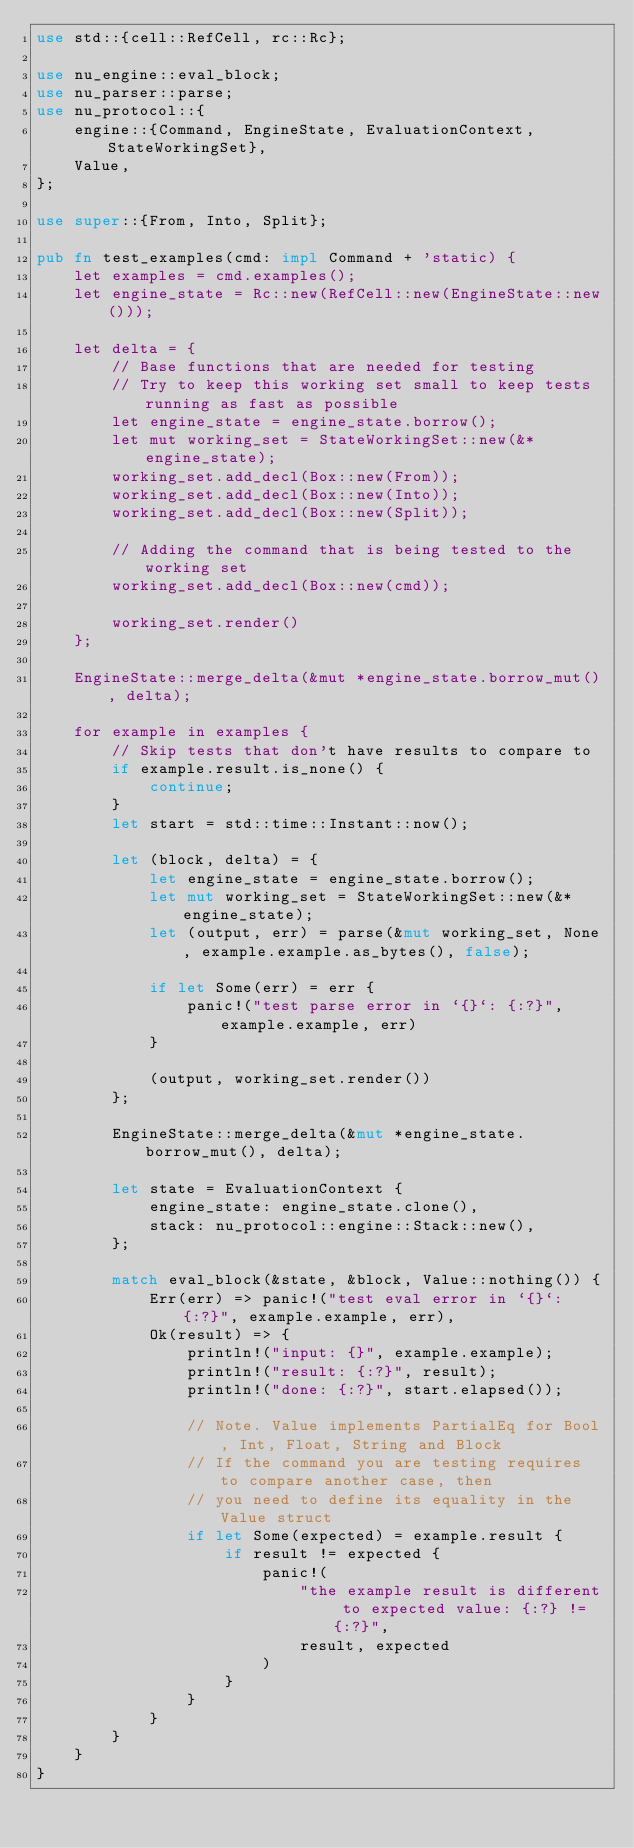<code> <loc_0><loc_0><loc_500><loc_500><_Rust_>use std::{cell::RefCell, rc::Rc};

use nu_engine::eval_block;
use nu_parser::parse;
use nu_protocol::{
    engine::{Command, EngineState, EvaluationContext, StateWorkingSet},
    Value,
};

use super::{From, Into, Split};

pub fn test_examples(cmd: impl Command + 'static) {
    let examples = cmd.examples();
    let engine_state = Rc::new(RefCell::new(EngineState::new()));

    let delta = {
        // Base functions that are needed for testing
        // Try to keep this working set small to keep tests running as fast as possible
        let engine_state = engine_state.borrow();
        let mut working_set = StateWorkingSet::new(&*engine_state);
        working_set.add_decl(Box::new(From));
        working_set.add_decl(Box::new(Into));
        working_set.add_decl(Box::new(Split));

        // Adding the command that is being tested to the working set
        working_set.add_decl(Box::new(cmd));

        working_set.render()
    };

    EngineState::merge_delta(&mut *engine_state.borrow_mut(), delta);

    for example in examples {
        // Skip tests that don't have results to compare to
        if example.result.is_none() {
            continue;
        }
        let start = std::time::Instant::now();

        let (block, delta) = {
            let engine_state = engine_state.borrow();
            let mut working_set = StateWorkingSet::new(&*engine_state);
            let (output, err) = parse(&mut working_set, None, example.example.as_bytes(), false);

            if let Some(err) = err {
                panic!("test parse error in `{}`: {:?}", example.example, err)
            }

            (output, working_set.render())
        };

        EngineState::merge_delta(&mut *engine_state.borrow_mut(), delta);

        let state = EvaluationContext {
            engine_state: engine_state.clone(),
            stack: nu_protocol::engine::Stack::new(),
        };

        match eval_block(&state, &block, Value::nothing()) {
            Err(err) => panic!("test eval error in `{}`: {:?}", example.example, err),
            Ok(result) => {
                println!("input: {}", example.example);
                println!("result: {:?}", result);
                println!("done: {:?}", start.elapsed());

                // Note. Value implements PartialEq for Bool, Int, Float, String and Block
                // If the command you are testing requires to compare another case, then
                // you need to define its equality in the Value struct
                if let Some(expected) = example.result {
                    if result != expected {
                        panic!(
                            "the example result is different to expected value: {:?} != {:?}",
                            result, expected
                        )
                    }
                }
            }
        }
    }
}
</code> 